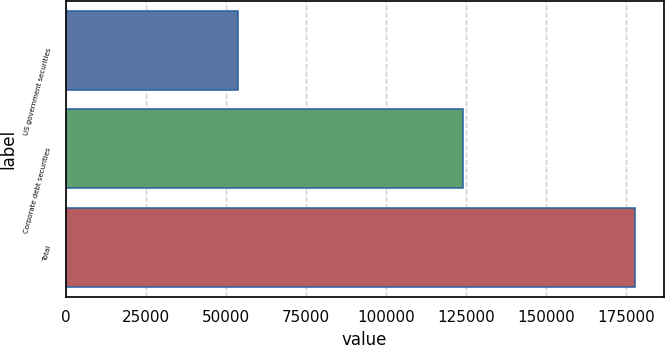Convert chart. <chart><loc_0><loc_0><loc_500><loc_500><bar_chart><fcel>US government securities<fcel>Corporate debt securities<fcel>Total<nl><fcel>53772<fcel>124080<fcel>177852<nl></chart> 